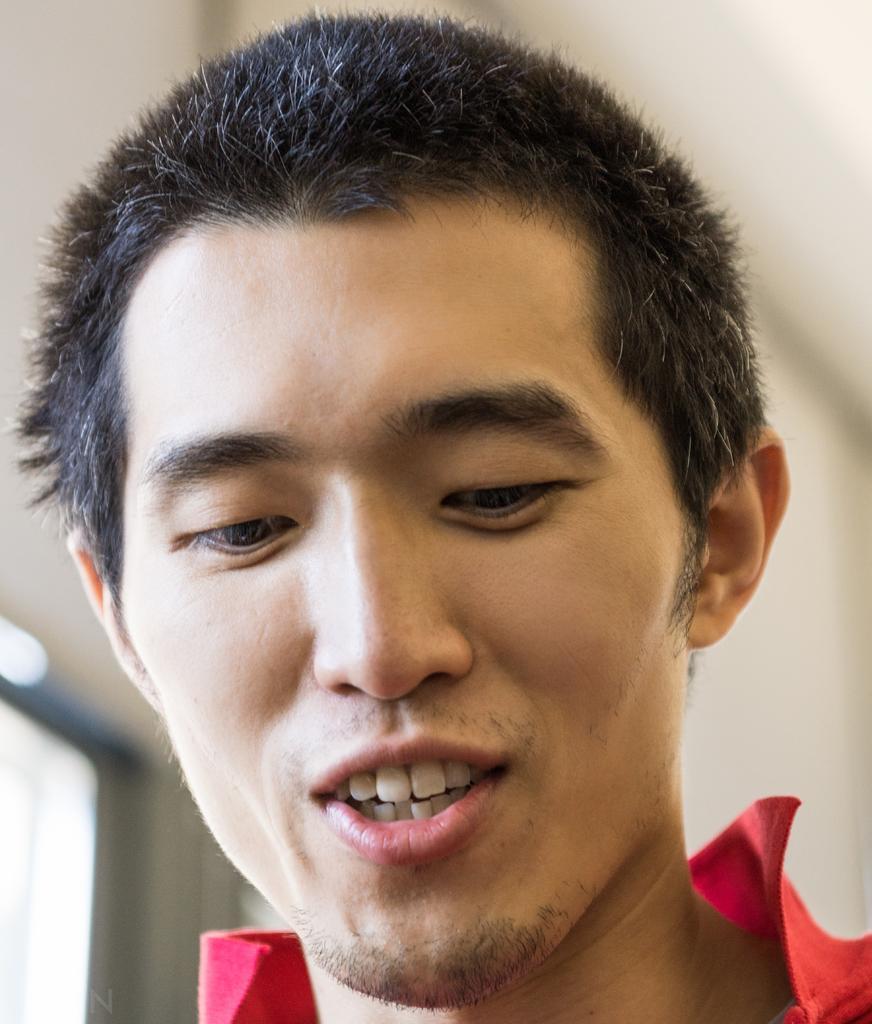Please provide a concise description of this image. In the image we can see there is a man and background of the image is little blurred. 